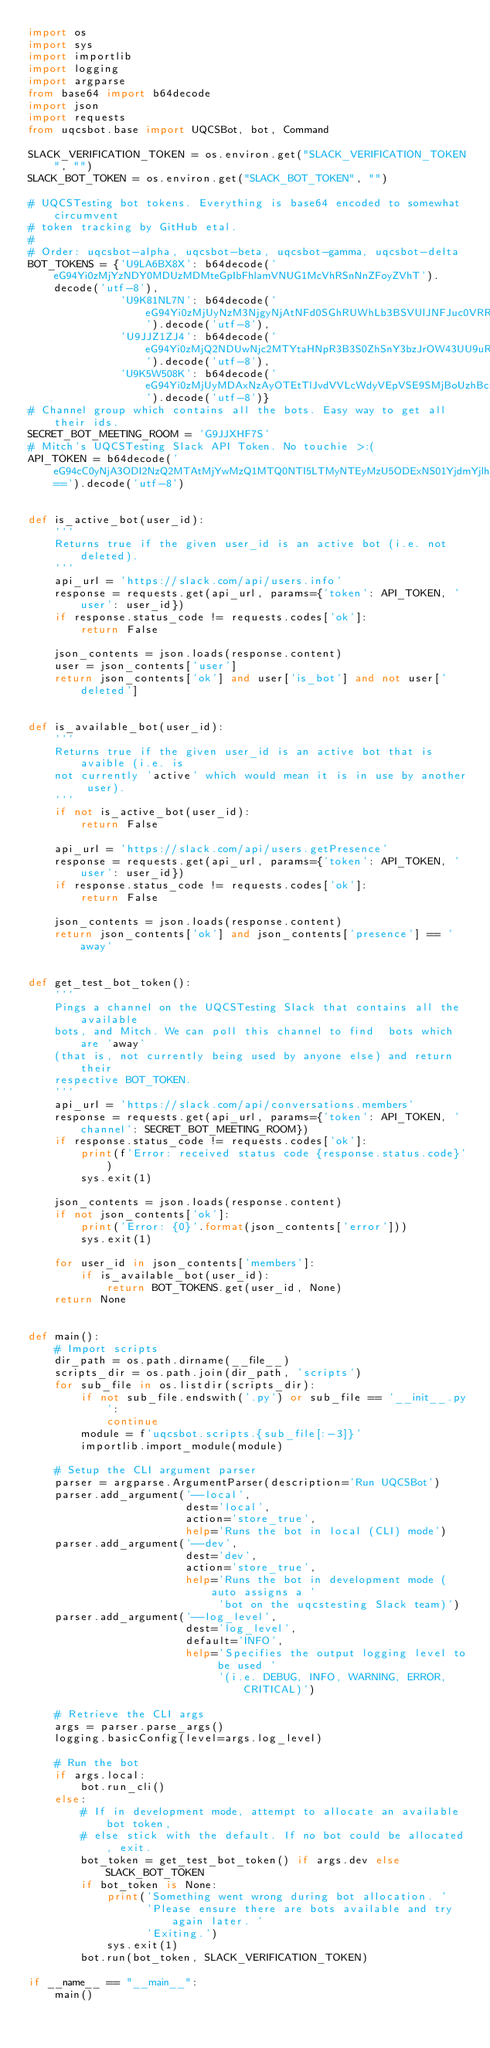<code> <loc_0><loc_0><loc_500><loc_500><_Python_>import os
import sys
import importlib
import logging
import argparse
from base64 import b64decode
import json
import requests
from uqcsbot.base import UQCSBot, bot, Command

SLACK_VERIFICATION_TOKEN = os.environ.get("SLACK_VERIFICATION_TOKEN", "")
SLACK_BOT_TOKEN = os.environ.get("SLACK_BOT_TOKEN", "")

# UQCSTesting bot tokens. Everything is base64 encoded to somewhat circumvent
# token tracking by GitHub etal.
#
# Order: uqcsbot-alpha, uqcsbot-beta, uqcsbot-gamma, uqcsbot-delta
BOT_TOKENS = {'U9LA6BX8X': b64decode('eG94Yi0zMjYzNDY0MDUzMDMteGpIbFhlamVNUG1McVhRSnNnZFoyZVhT').decode('utf-8'),
              'U9K81NL7N': b64decode('eG94Yi0zMjUyNzM3NjgyNjAtNFd0SGhRUWhLb3BSVUlJNFJuc0VRRXJL').decode('utf-8'),
              'U9JJZ1ZJ4': b64decode('eG94Yi0zMjQ2NDUwNjc2MTYtaHNpR3B3S0ZhSnY3bzJrOW43UU9uRXFp').decode('utf-8'),
              'U9K5W508K': b64decode('eG94Yi0zMjUyMDAxNzAyOTEtTlJvdVVLcWdyVEpVSE9SMjBoUzhBcnhW').decode('utf-8')}
# Channel group which contains all the bots. Easy way to get all their ids.
SECRET_BOT_MEETING_ROOM = 'G9JJXHF7S'
# Mitch's UQCSTesting Slack API Token. No touchie >:(
API_TOKEN = b64decode('eG94cC0yNjA3ODI2NzQ2MTAtMjYwMzQ1MTQ0NTI5LTMyNTEyMzU5ODExNS01YjdmYjlhYzAyZWYzNDAyNTYyMTJmY2Q2YjQ1NmEyYg==').decode('utf-8')


def is_active_bot(user_id):
    '''
    Returns true if the given user_id is an active bot (i.e. not deleted).
    '''
    api_url = 'https://slack.com/api/users.info'
    response = requests.get(api_url, params={'token': API_TOKEN, 'user': user_id})
    if response.status_code != requests.codes['ok']:
        return False

    json_contents = json.loads(response.content)
    user = json_contents['user']
    return json_contents['ok'] and user['is_bot'] and not user['deleted']


def is_available_bot(user_id):
    '''
    Returns true if the given user_id is an active bot that is avaible (i.e. is
    not currently 'active' which would mean it is in use by another user).
    '''
    if not is_active_bot(user_id):
        return False

    api_url = 'https://slack.com/api/users.getPresence'
    response = requests.get(api_url, params={'token': API_TOKEN, 'user': user_id})
    if response.status_code != requests.codes['ok']:
        return False

    json_contents = json.loads(response.content)
    return json_contents['ok'] and json_contents['presence'] == 'away'


def get_test_bot_token():
    '''
    Pings a channel on the UQCSTesting Slack that contains all the available
    bots, and Mitch. We can poll this channel to find  bots which are 'away'
    (that is, not currently being used by anyone else) and return their
    respective BOT_TOKEN.
    '''
    api_url = 'https://slack.com/api/conversations.members'
    response = requests.get(api_url, params={'token': API_TOKEN, 'channel': SECRET_BOT_MEETING_ROOM})
    if response.status_code != requests.codes['ok']:
        print(f'Error: received status code {response.status.code}')
        sys.exit(1)

    json_contents = json.loads(response.content)
    if not json_contents['ok']:
        print('Error: {0}'.format(json_contents['error']))
        sys.exit(1)

    for user_id in json_contents['members']:
        if is_available_bot(user_id):
            return BOT_TOKENS.get(user_id, None)
    return None


def main():
    # Import scripts
    dir_path = os.path.dirname(__file__)
    scripts_dir = os.path.join(dir_path, 'scripts')
    for sub_file in os.listdir(scripts_dir):
        if not sub_file.endswith('.py') or sub_file == '__init__.py':
            continue
        module = f'uqcsbot.scripts.{sub_file[:-3]}'
        importlib.import_module(module)

    # Setup the CLI argument parser
    parser = argparse.ArgumentParser(description='Run UQCSBot')
    parser.add_argument('--local',
                        dest='local',
                        action='store_true',
                        help='Runs the bot in local (CLI) mode')
    parser.add_argument('--dev',
                        dest='dev',
                        action='store_true',
                        help='Runs the bot in development mode (auto assigns a '
                             'bot on the uqcstesting Slack team)')
    parser.add_argument('--log_level',
                        dest='log_level',
                        default='INFO',
                        help='Specifies the output logging level to be used '
                             '(i.e. DEBUG, INFO, WARNING, ERROR, CRITICAL)')

    # Retrieve the CLI args
    args = parser.parse_args()
    logging.basicConfig(level=args.log_level)

    # Run the bot
    if args.local:
        bot.run_cli()
    else:
        # If in development mode, attempt to allocate an available bot token,
        # else stick with the default. If no bot could be allocated, exit.
        bot_token = get_test_bot_token() if args.dev else SLACK_BOT_TOKEN
        if bot_token is None:
            print('Something went wrong during bot allocation. '
                  'Please ensure there are bots available and try again later. '
                  'Exiting.')
            sys.exit(1)
        bot.run(bot_token, SLACK_VERIFICATION_TOKEN)

if __name__ == "__main__":
    main()
</code> 